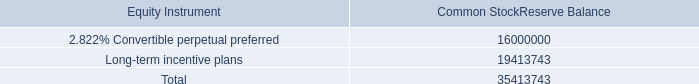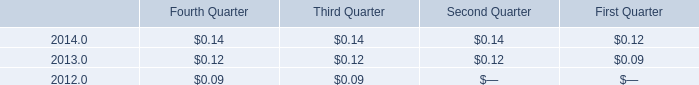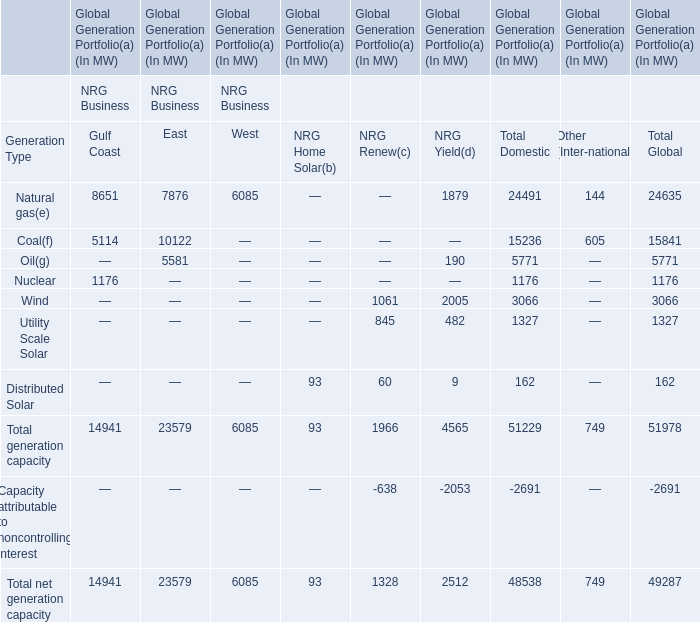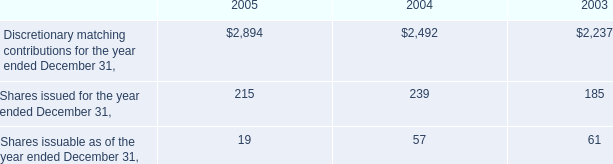What is the sum of the Total generation capacity in the sections where Oil is positive? 
Computations: (((23579 + 4565) + 51229) + 51978)
Answer: 131351.0. 